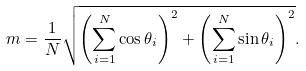<formula> <loc_0><loc_0><loc_500><loc_500>m = \frac { 1 } { N } \sqrt { \left ( \sum _ { i = 1 } ^ { N } \cos \theta _ { i } \right ) ^ { 2 } + \left ( \sum _ { i = 1 } ^ { N } \sin \theta _ { i } \right ) ^ { 2 } } .</formula> 